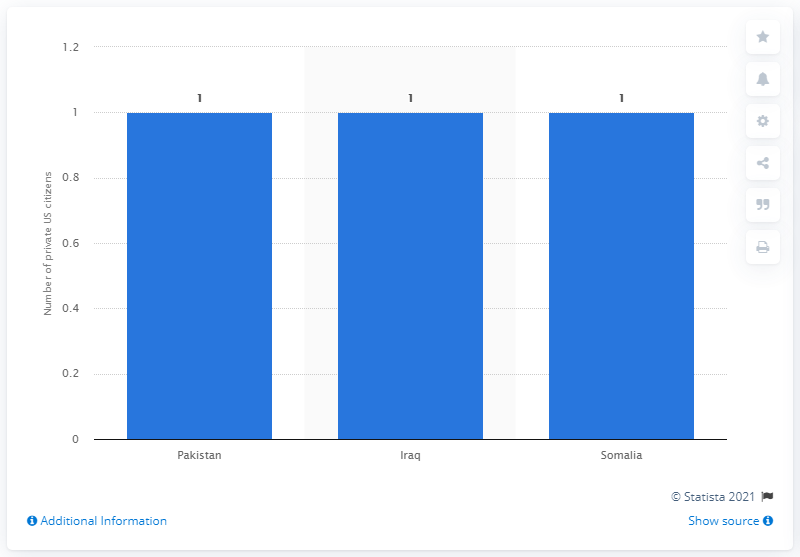Draw attention to some important aspects in this diagram. In 2011, a US citizen was taken hostage by terrorists in Pakistan. 